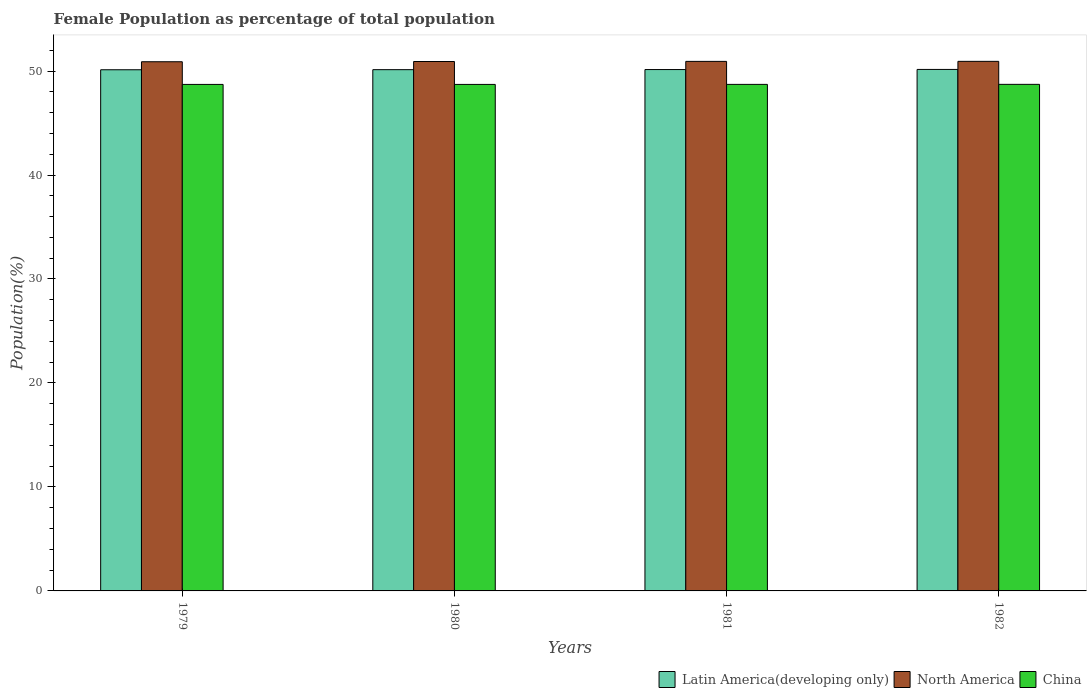How many different coloured bars are there?
Provide a short and direct response. 3. How many groups of bars are there?
Provide a succinct answer. 4. What is the label of the 1st group of bars from the left?
Offer a very short reply. 1979. What is the female population in in Latin America(developing only) in 1980?
Offer a very short reply. 50.13. Across all years, what is the maximum female population in in North America?
Keep it short and to the point. 50.93. Across all years, what is the minimum female population in in North America?
Offer a very short reply. 50.89. In which year was the female population in in China maximum?
Give a very brief answer. 1982. In which year was the female population in in Latin America(developing only) minimum?
Your answer should be compact. 1979. What is the total female population in in China in the graph?
Your answer should be compact. 194.86. What is the difference between the female population in in China in 1980 and that in 1982?
Offer a very short reply. -0.01. What is the difference between the female population in in Latin America(developing only) in 1982 and the female population in in North America in 1980?
Provide a short and direct response. -0.76. What is the average female population in in Latin America(developing only) per year?
Provide a short and direct response. 50.14. In the year 1981, what is the difference between the female population in in China and female population in in Latin America(developing only)?
Offer a very short reply. -1.43. What is the ratio of the female population in in China in 1981 to that in 1982?
Your answer should be very brief. 1. Is the female population in in Latin America(developing only) in 1979 less than that in 1981?
Offer a very short reply. Yes. What is the difference between the highest and the second highest female population in in Latin America(developing only)?
Provide a succinct answer. 0.01. What is the difference between the highest and the lowest female population in in Latin America(developing only)?
Keep it short and to the point. 0.03. Is the sum of the female population in in Latin America(developing only) in 1981 and 1982 greater than the maximum female population in in China across all years?
Provide a short and direct response. Yes. What does the 1st bar from the left in 1980 represents?
Your response must be concise. Latin America(developing only). What does the 3rd bar from the right in 1981 represents?
Your answer should be very brief. Latin America(developing only). Is it the case that in every year, the sum of the female population in in Latin America(developing only) and female population in in China is greater than the female population in in North America?
Your answer should be very brief. Yes. How many bars are there?
Offer a very short reply. 12. Are all the bars in the graph horizontal?
Your answer should be compact. No. How many years are there in the graph?
Provide a succinct answer. 4. Are the values on the major ticks of Y-axis written in scientific E-notation?
Your answer should be compact. No. Does the graph contain grids?
Your answer should be very brief. No. Where does the legend appear in the graph?
Offer a terse response. Bottom right. How are the legend labels stacked?
Provide a short and direct response. Horizontal. What is the title of the graph?
Give a very brief answer. Female Population as percentage of total population. What is the label or title of the Y-axis?
Offer a very short reply. Population(%). What is the Population(%) in Latin America(developing only) in 1979?
Give a very brief answer. 50.12. What is the Population(%) in North America in 1979?
Offer a very short reply. 50.89. What is the Population(%) of China in 1979?
Keep it short and to the point. 48.71. What is the Population(%) in Latin America(developing only) in 1980?
Give a very brief answer. 50.13. What is the Population(%) in North America in 1980?
Ensure brevity in your answer.  50.92. What is the Population(%) of China in 1980?
Ensure brevity in your answer.  48.71. What is the Population(%) in Latin America(developing only) in 1981?
Make the answer very short. 50.14. What is the Population(%) of North America in 1981?
Your answer should be very brief. 50.93. What is the Population(%) in China in 1981?
Your answer should be compact. 48.71. What is the Population(%) of Latin America(developing only) in 1982?
Provide a short and direct response. 50.15. What is the Population(%) in North America in 1982?
Keep it short and to the point. 50.93. What is the Population(%) of China in 1982?
Offer a terse response. 48.72. Across all years, what is the maximum Population(%) of Latin America(developing only)?
Offer a very short reply. 50.15. Across all years, what is the maximum Population(%) of North America?
Provide a succinct answer. 50.93. Across all years, what is the maximum Population(%) of China?
Ensure brevity in your answer.  48.72. Across all years, what is the minimum Population(%) in Latin America(developing only)?
Offer a terse response. 50.12. Across all years, what is the minimum Population(%) in North America?
Offer a very short reply. 50.89. Across all years, what is the minimum Population(%) in China?
Keep it short and to the point. 48.71. What is the total Population(%) in Latin America(developing only) in the graph?
Provide a succinct answer. 200.55. What is the total Population(%) of North America in the graph?
Keep it short and to the point. 203.66. What is the total Population(%) in China in the graph?
Keep it short and to the point. 194.86. What is the difference between the Population(%) in Latin America(developing only) in 1979 and that in 1980?
Give a very brief answer. -0.01. What is the difference between the Population(%) of North America in 1979 and that in 1980?
Provide a short and direct response. -0.02. What is the difference between the Population(%) in China in 1979 and that in 1980?
Give a very brief answer. -0. What is the difference between the Population(%) of Latin America(developing only) in 1979 and that in 1981?
Provide a succinct answer. -0.02. What is the difference between the Population(%) of North America in 1979 and that in 1981?
Ensure brevity in your answer.  -0.04. What is the difference between the Population(%) of China in 1979 and that in 1981?
Offer a very short reply. -0. What is the difference between the Population(%) in Latin America(developing only) in 1979 and that in 1982?
Your answer should be compact. -0.03. What is the difference between the Population(%) in North America in 1979 and that in 1982?
Your answer should be compact. -0.04. What is the difference between the Population(%) in China in 1979 and that in 1982?
Make the answer very short. -0.01. What is the difference between the Population(%) of Latin America(developing only) in 1980 and that in 1981?
Your response must be concise. -0.01. What is the difference between the Population(%) of North America in 1980 and that in 1981?
Provide a succinct answer. -0.01. What is the difference between the Population(%) in China in 1980 and that in 1981?
Make the answer very short. -0. What is the difference between the Population(%) in Latin America(developing only) in 1980 and that in 1982?
Your response must be concise. -0.02. What is the difference between the Population(%) in North America in 1980 and that in 1982?
Provide a short and direct response. -0.01. What is the difference between the Population(%) in China in 1980 and that in 1982?
Your response must be concise. -0.01. What is the difference between the Population(%) in Latin America(developing only) in 1981 and that in 1982?
Offer a very short reply. -0.01. What is the difference between the Population(%) in North America in 1981 and that in 1982?
Your answer should be very brief. -0. What is the difference between the Population(%) in China in 1981 and that in 1982?
Provide a succinct answer. -0. What is the difference between the Population(%) of Latin America(developing only) in 1979 and the Population(%) of North America in 1980?
Ensure brevity in your answer.  -0.79. What is the difference between the Population(%) in Latin America(developing only) in 1979 and the Population(%) in China in 1980?
Your answer should be compact. 1.41. What is the difference between the Population(%) of North America in 1979 and the Population(%) of China in 1980?
Make the answer very short. 2.18. What is the difference between the Population(%) of Latin America(developing only) in 1979 and the Population(%) of North America in 1981?
Your answer should be compact. -0.81. What is the difference between the Population(%) in Latin America(developing only) in 1979 and the Population(%) in China in 1981?
Provide a short and direct response. 1.41. What is the difference between the Population(%) of North America in 1979 and the Population(%) of China in 1981?
Offer a very short reply. 2.18. What is the difference between the Population(%) of Latin America(developing only) in 1979 and the Population(%) of North America in 1982?
Offer a terse response. -0.81. What is the difference between the Population(%) of Latin America(developing only) in 1979 and the Population(%) of China in 1982?
Your response must be concise. 1.4. What is the difference between the Population(%) in North America in 1979 and the Population(%) in China in 1982?
Your response must be concise. 2.17. What is the difference between the Population(%) of Latin America(developing only) in 1980 and the Population(%) of North America in 1981?
Ensure brevity in your answer.  -0.8. What is the difference between the Population(%) in Latin America(developing only) in 1980 and the Population(%) in China in 1981?
Offer a very short reply. 1.42. What is the difference between the Population(%) in North America in 1980 and the Population(%) in China in 1981?
Your response must be concise. 2.2. What is the difference between the Population(%) of Latin America(developing only) in 1980 and the Population(%) of North America in 1982?
Make the answer very short. -0.8. What is the difference between the Population(%) of Latin America(developing only) in 1980 and the Population(%) of China in 1982?
Offer a terse response. 1.41. What is the difference between the Population(%) in North America in 1980 and the Population(%) in China in 1982?
Provide a succinct answer. 2.2. What is the difference between the Population(%) of Latin America(developing only) in 1981 and the Population(%) of North America in 1982?
Ensure brevity in your answer.  -0.79. What is the difference between the Population(%) in Latin America(developing only) in 1981 and the Population(%) in China in 1982?
Ensure brevity in your answer.  1.42. What is the difference between the Population(%) of North America in 1981 and the Population(%) of China in 1982?
Provide a short and direct response. 2.21. What is the average Population(%) of Latin America(developing only) per year?
Keep it short and to the point. 50.14. What is the average Population(%) in North America per year?
Your answer should be compact. 50.92. What is the average Population(%) in China per year?
Your answer should be very brief. 48.71. In the year 1979, what is the difference between the Population(%) in Latin America(developing only) and Population(%) in North America?
Your response must be concise. -0.77. In the year 1979, what is the difference between the Population(%) in Latin America(developing only) and Population(%) in China?
Your answer should be compact. 1.41. In the year 1979, what is the difference between the Population(%) of North America and Population(%) of China?
Your response must be concise. 2.18. In the year 1980, what is the difference between the Population(%) in Latin America(developing only) and Population(%) in North America?
Your response must be concise. -0.78. In the year 1980, what is the difference between the Population(%) of Latin America(developing only) and Population(%) of China?
Your response must be concise. 1.42. In the year 1980, what is the difference between the Population(%) of North America and Population(%) of China?
Offer a terse response. 2.2. In the year 1981, what is the difference between the Population(%) in Latin America(developing only) and Population(%) in North America?
Provide a short and direct response. -0.79. In the year 1981, what is the difference between the Population(%) in Latin America(developing only) and Population(%) in China?
Provide a short and direct response. 1.43. In the year 1981, what is the difference between the Population(%) of North America and Population(%) of China?
Keep it short and to the point. 2.21. In the year 1982, what is the difference between the Population(%) of Latin America(developing only) and Population(%) of North America?
Keep it short and to the point. -0.78. In the year 1982, what is the difference between the Population(%) of Latin America(developing only) and Population(%) of China?
Provide a succinct answer. 1.43. In the year 1982, what is the difference between the Population(%) of North America and Population(%) of China?
Make the answer very short. 2.21. What is the ratio of the Population(%) in North America in 1979 to that in 1980?
Your answer should be compact. 1. What is the ratio of the Population(%) in China in 1979 to that in 1980?
Make the answer very short. 1. What is the ratio of the Population(%) in Latin America(developing only) in 1979 to that in 1981?
Offer a terse response. 1. What is the ratio of the Population(%) in Latin America(developing only) in 1979 to that in 1982?
Ensure brevity in your answer.  1. What is the ratio of the Population(%) of Latin America(developing only) in 1980 to that in 1981?
Provide a short and direct response. 1. What is the ratio of the Population(%) in North America in 1980 to that in 1981?
Keep it short and to the point. 1. What is the ratio of the Population(%) in Latin America(developing only) in 1980 to that in 1982?
Ensure brevity in your answer.  1. What is the ratio of the Population(%) of China in 1980 to that in 1982?
Make the answer very short. 1. What is the difference between the highest and the second highest Population(%) in Latin America(developing only)?
Keep it short and to the point. 0.01. What is the difference between the highest and the second highest Population(%) of North America?
Make the answer very short. 0. What is the difference between the highest and the second highest Population(%) in China?
Ensure brevity in your answer.  0. What is the difference between the highest and the lowest Population(%) of Latin America(developing only)?
Make the answer very short. 0.03. What is the difference between the highest and the lowest Population(%) in North America?
Offer a terse response. 0.04. What is the difference between the highest and the lowest Population(%) in China?
Ensure brevity in your answer.  0.01. 